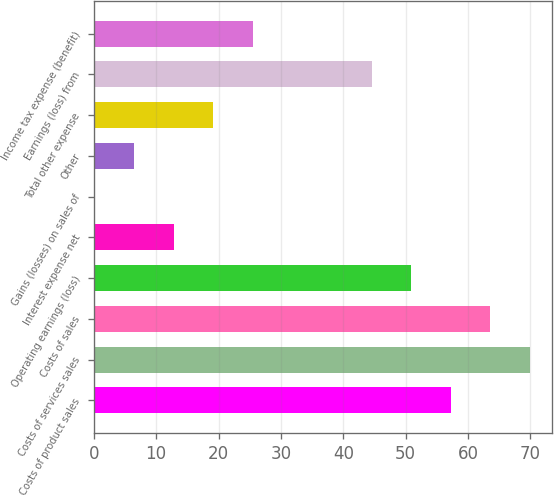Convert chart. <chart><loc_0><loc_0><loc_500><loc_500><bar_chart><fcel>Costs of product sales<fcel>Costs of services sales<fcel>Costs of sales<fcel>Operating earnings (loss)<fcel>Interest expense net<fcel>Gains (losses) on sales of<fcel>Other<fcel>Total other expense<fcel>Earnings (loss) from<fcel>Income tax expense (benefit)<nl><fcel>57.25<fcel>69.95<fcel>63.6<fcel>50.9<fcel>12.8<fcel>0.1<fcel>6.45<fcel>19.15<fcel>44.55<fcel>25.5<nl></chart> 